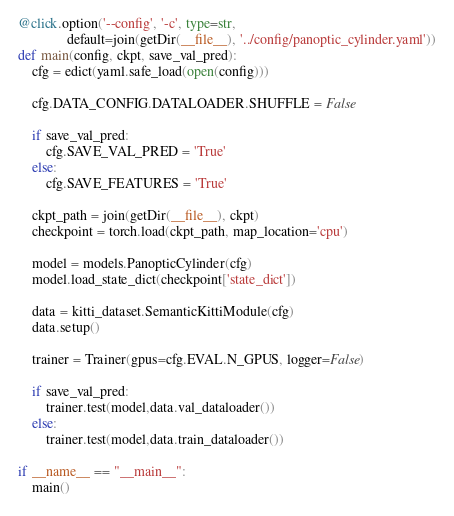<code> <loc_0><loc_0><loc_500><loc_500><_Python_>@click.option('--config', '-c', type=str,
              default=join(getDir(__file__), '../config/panoptic_cylinder.yaml'))
def main(config, ckpt, save_val_pred):
    cfg = edict(yaml.safe_load(open(config)))

    cfg.DATA_CONFIG.DATALOADER.SHUFFLE = False

    if save_val_pred:
        cfg.SAVE_VAL_PRED = 'True'
    else:
        cfg.SAVE_FEATURES = 'True'

    ckpt_path = join(getDir(__file__), ckpt)
    checkpoint = torch.load(ckpt_path, map_location='cpu')

    model = models.PanopticCylinder(cfg)
    model.load_state_dict(checkpoint['state_dict'])

    data = kitti_dataset.SemanticKittiModule(cfg)
    data.setup()

    trainer = Trainer(gpus=cfg.EVAL.N_GPUS, logger=False)

    if save_val_pred:
        trainer.test(model,data.val_dataloader())
    else:
        trainer.test(model,data.train_dataloader())

if __name__ == "__main__":
    main()
</code> 